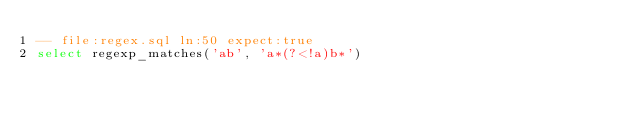Convert code to text. <code><loc_0><loc_0><loc_500><loc_500><_SQL_>-- file:regex.sql ln:50 expect:true
select regexp_matches('ab', 'a*(?<!a)b*')
</code> 